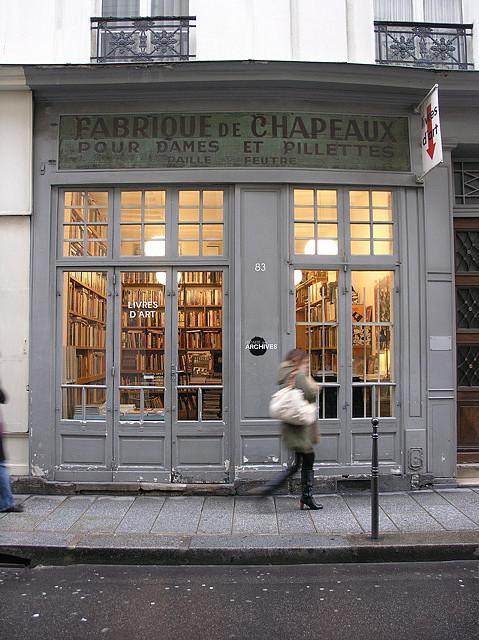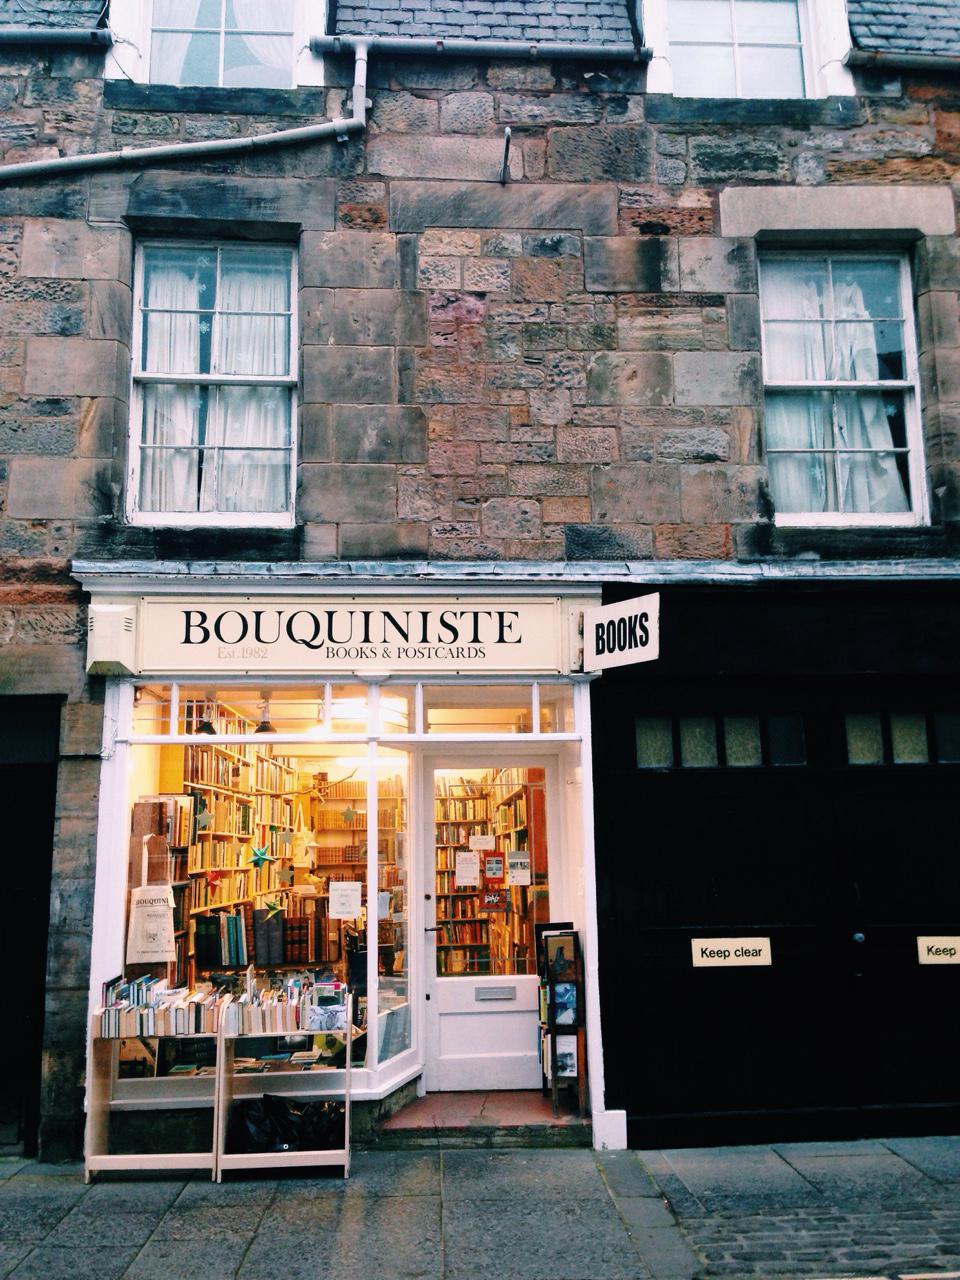The first image is the image on the left, the second image is the image on the right. Analyze the images presented: Is the assertion "Atleast one door is brown" valid? Answer yes or no. No. The first image is the image on the left, the second image is the image on the right. Analyze the images presented: Is the assertion "A bookstore exterior has lattice above big display windows, a shield shape over paned glass, and a statue of a figure inset in an arch on the building's front." valid? Answer yes or no. No. 